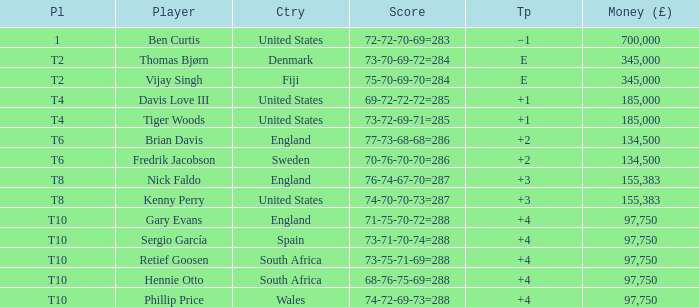What is the To Par of Fredrik Jacobson? 2.0. 